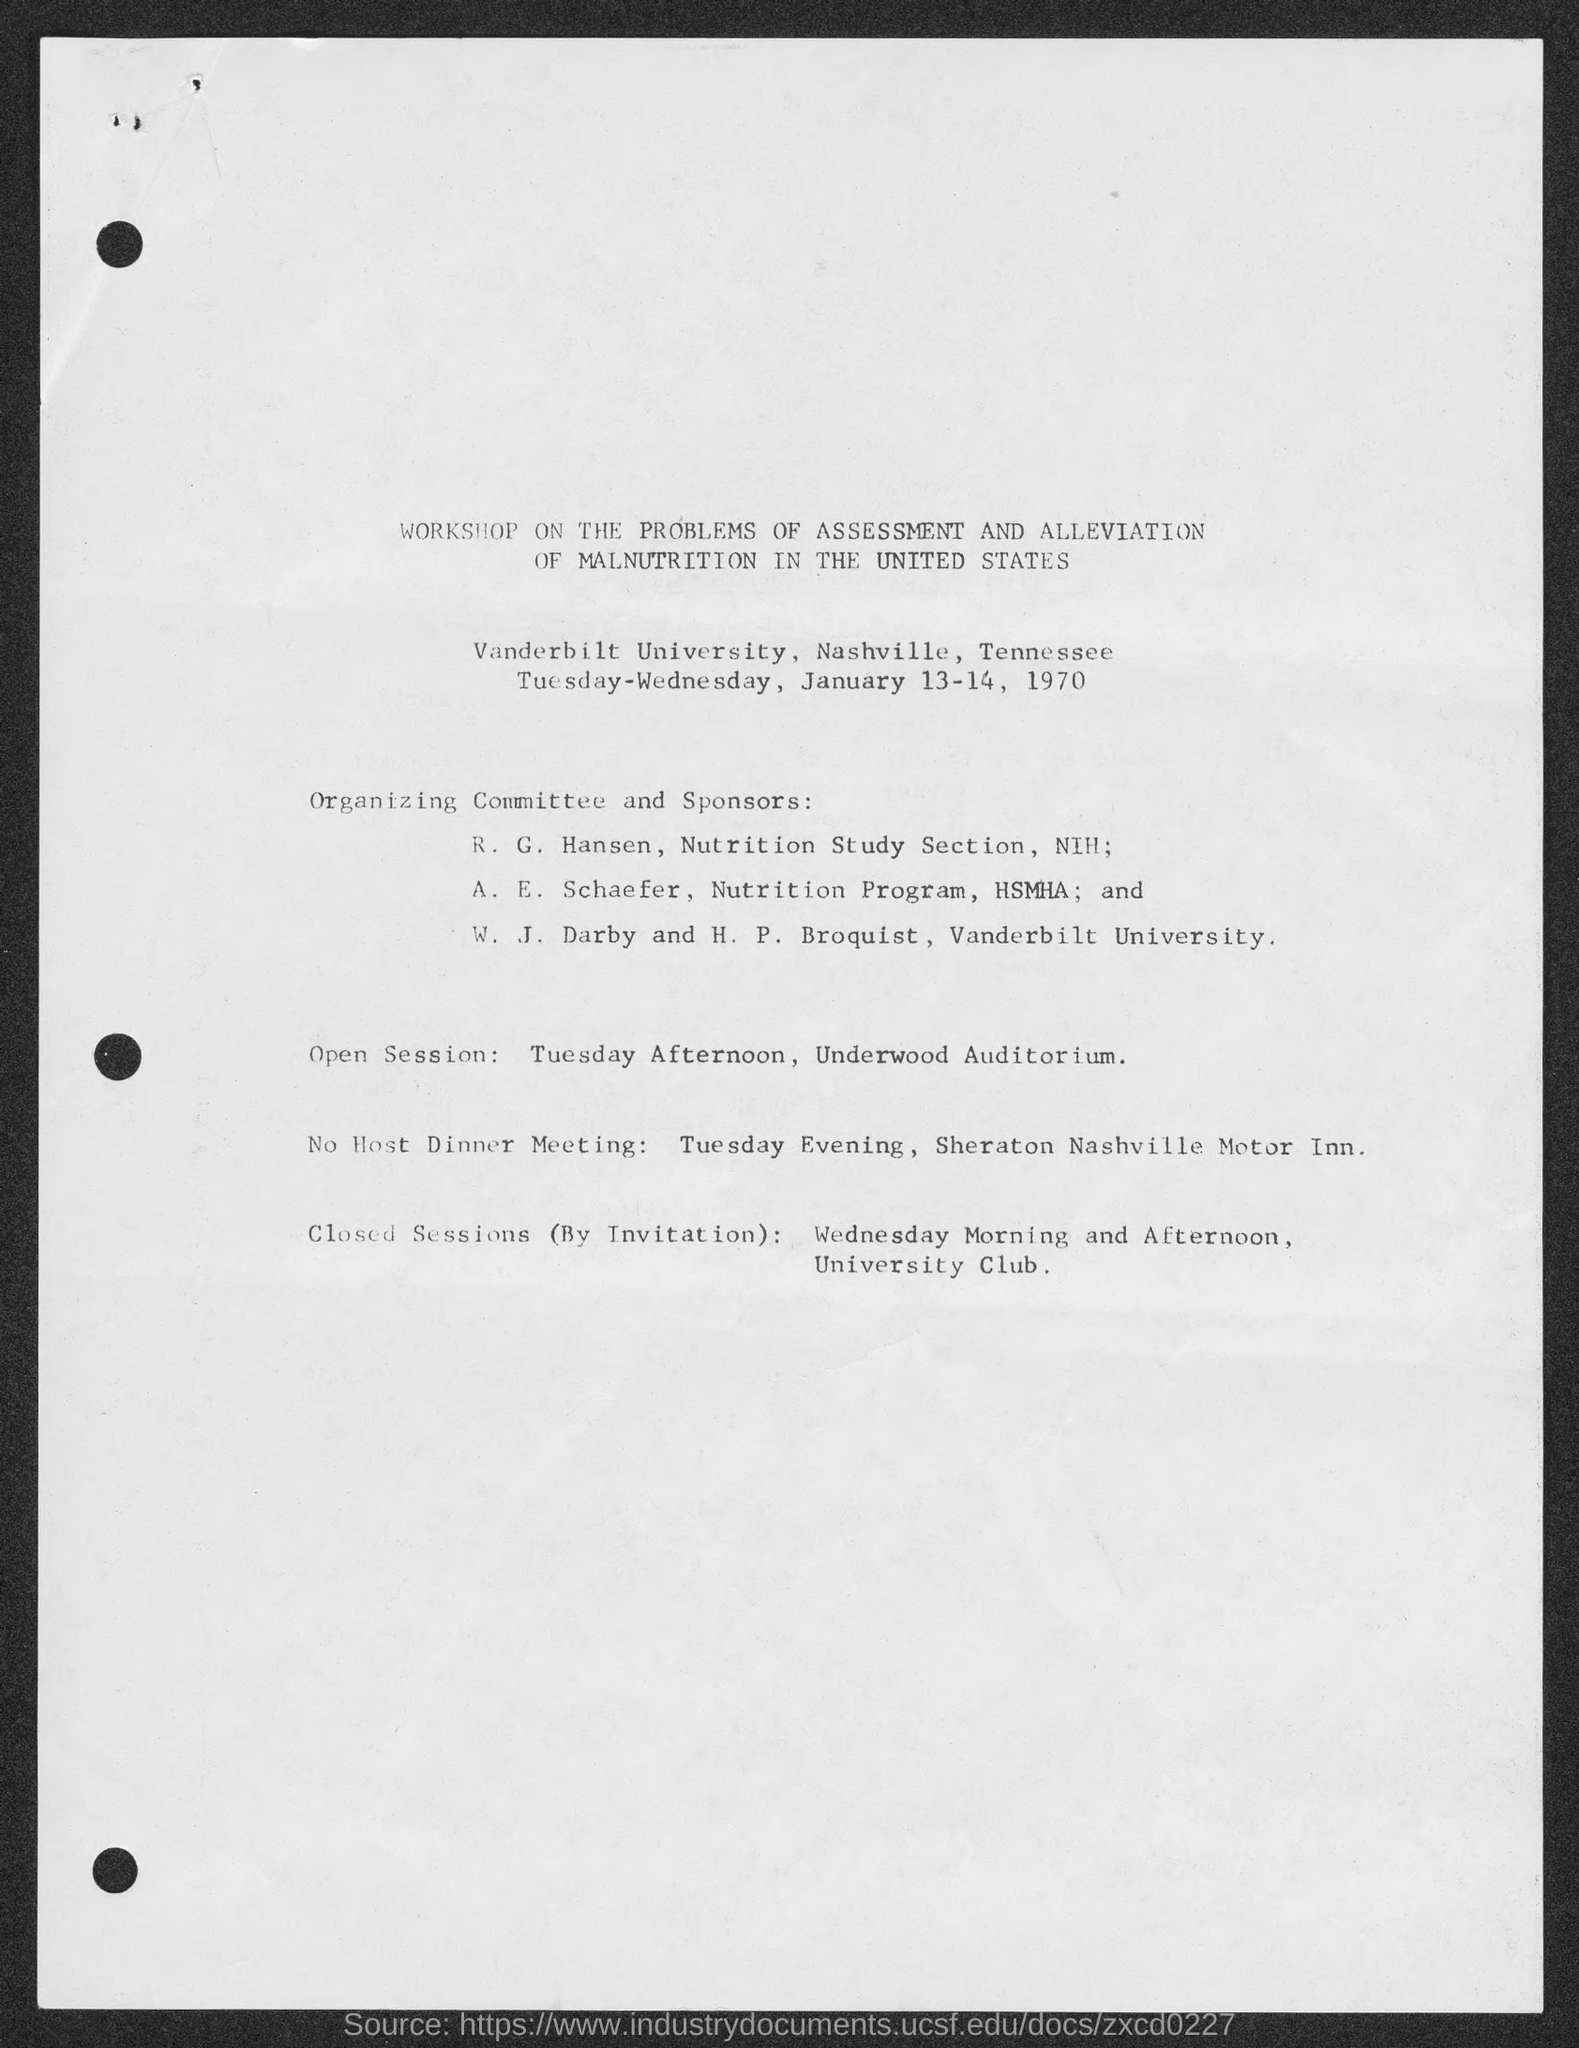List a handful of essential elements in this visual. The closed sessions are scheduled at the University Club. The open session is scheduled in Underwood Auditorium. W. J. Darby and H. P. Broquist were associated with Vanderbilt University. The No Host Dinner Meeting is scheduled for Tuesday evening. 